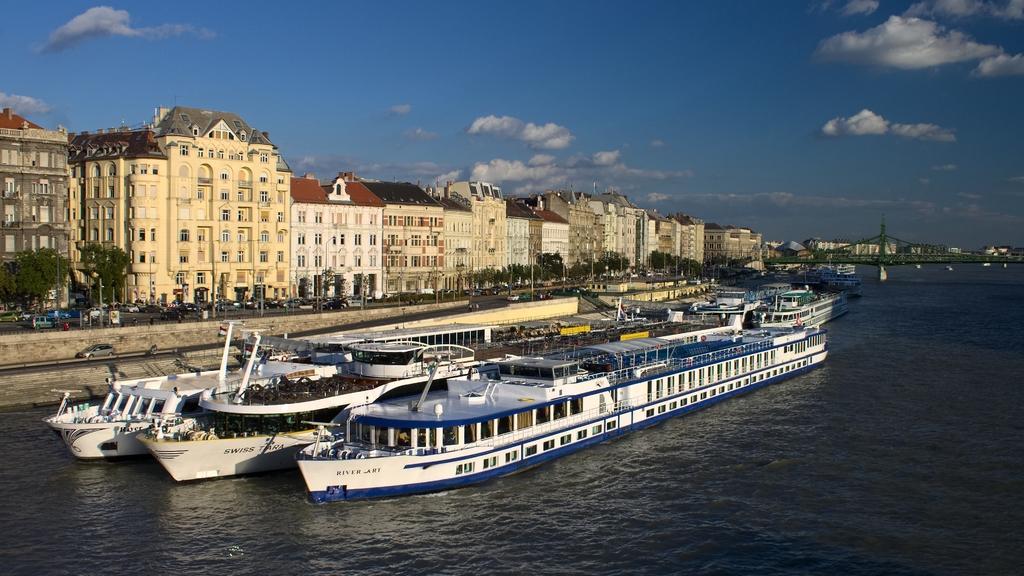Please provide a concise description of this image. In the picture I can see some ships which are moving on water, there are some vehicles moving on road, there are buildings, on right side of the picture there is bridge and top of the picture there is clear sky. 